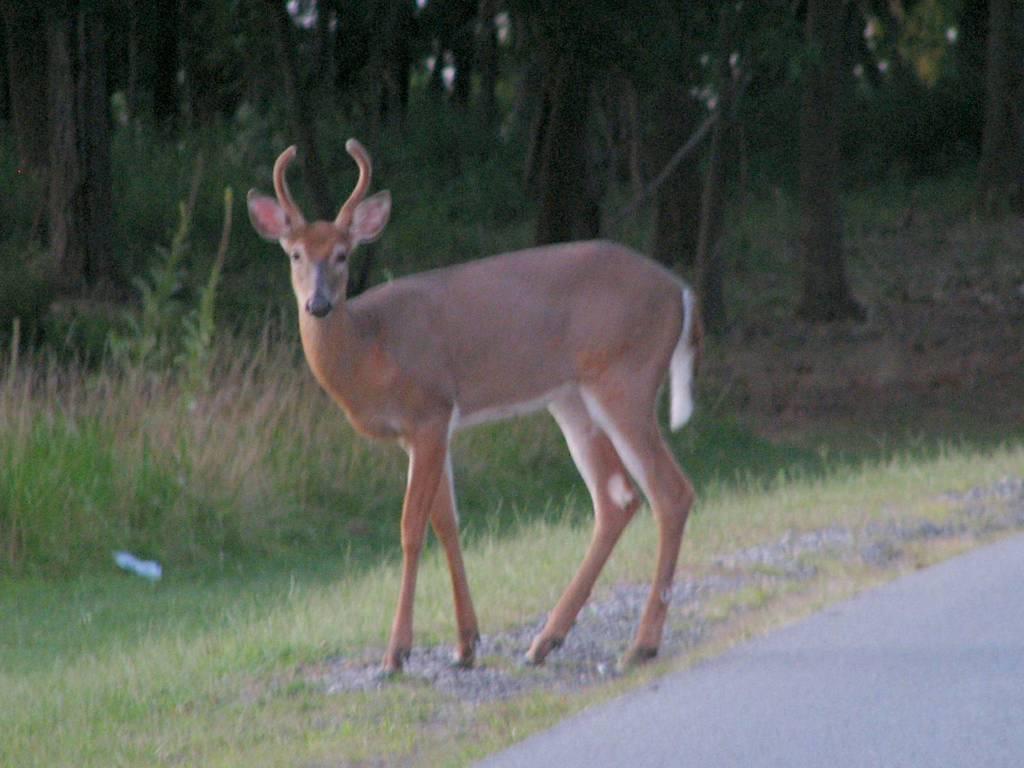Describe this image in one or two sentences. In this image in front there is a road and we can see a deer. At the bottom of the image there is grass on the surface. In the background of the image there are trees. 